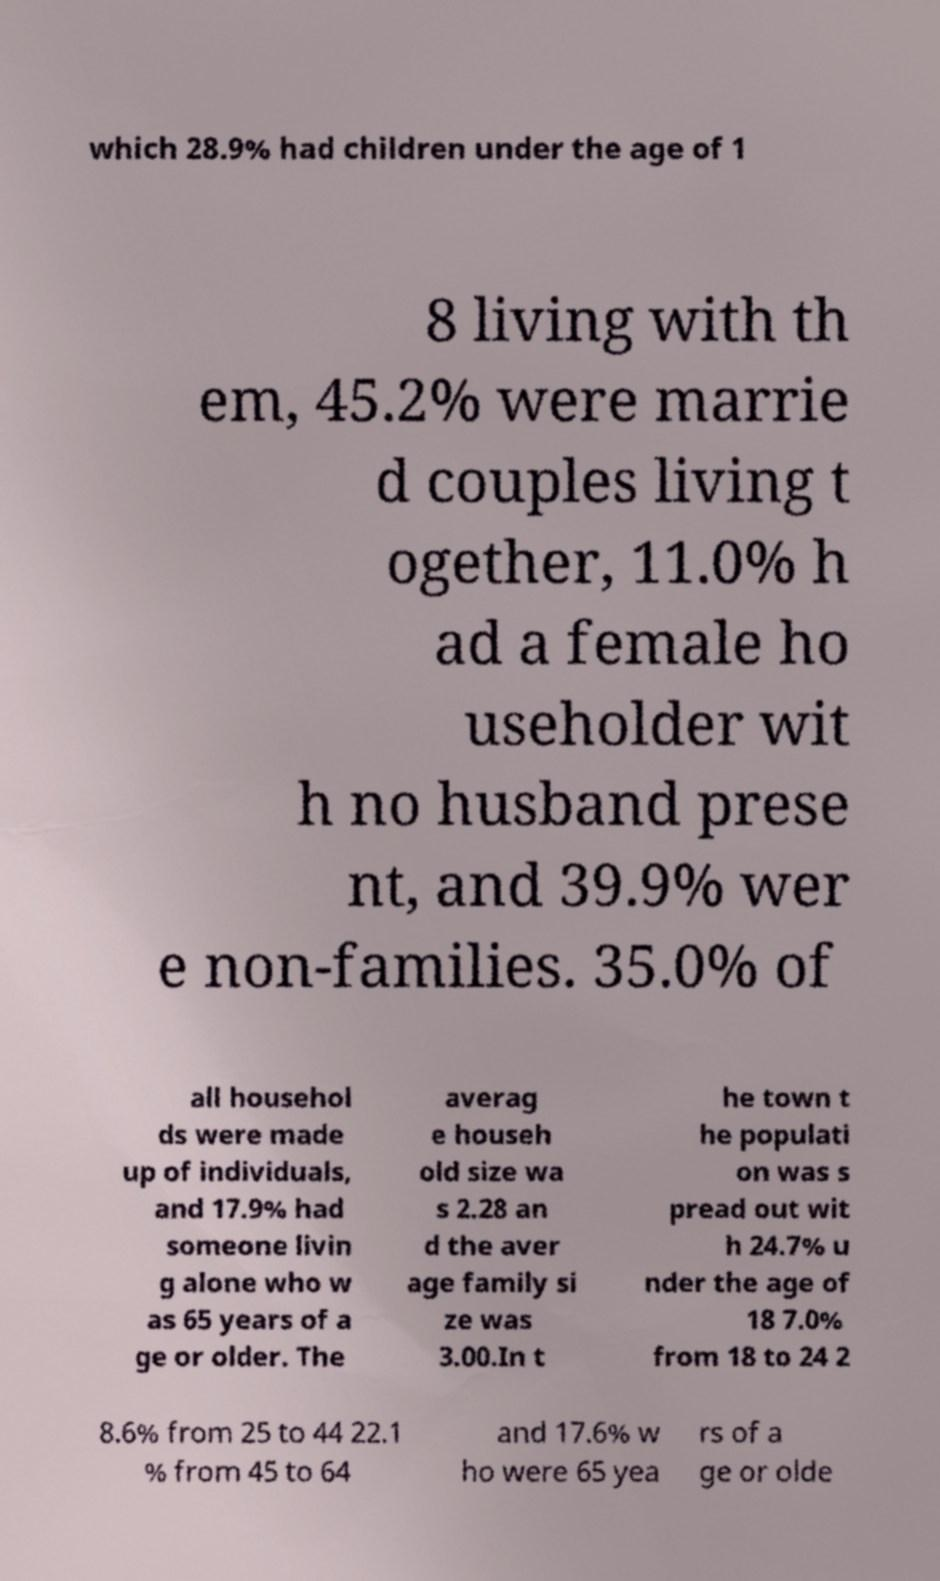There's text embedded in this image that I need extracted. Can you transcribe it verbatim? which 28.9% had children under the age of 1 8 living with th em, 45.2% were marrie d couples living t ogether, 11.0% h ad a female ho useholder wit h no husband prese nt, and 39.9% wer e non-families. 35.0% of all househol ds were made up of individuals, and 17.9% had someone livin g alone who w as 65 years of a ge or older. The averag e househ old size wa s 2.28 an d the aver age family si ze was 3.00.In t he town t he populati on was s pread out wit h 24.7% u nder the age of 18 7.0% from 18 to 24 2 8.6% from 25 to 44 22.1 % from 45 to 64 and 17.6% w ho were 65 yea rs of a ge or olde 